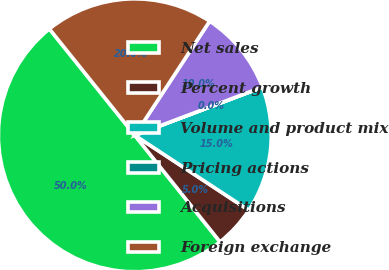<chart> <loc_0><loc_0><loc_500><loc_500><pie_chart><fcel>Net sales<fcel>Percent growth<fcel>Volume and product mix<fcel>Pricing actions<fcel>Acquisitions<fcel>Foreign exchange<nl><fcel>49.97%<fcel>5.01%<fcel>15.0%<fcel>0.01%<fcel>10.01%<fcel>20.0%<nl></chart> 